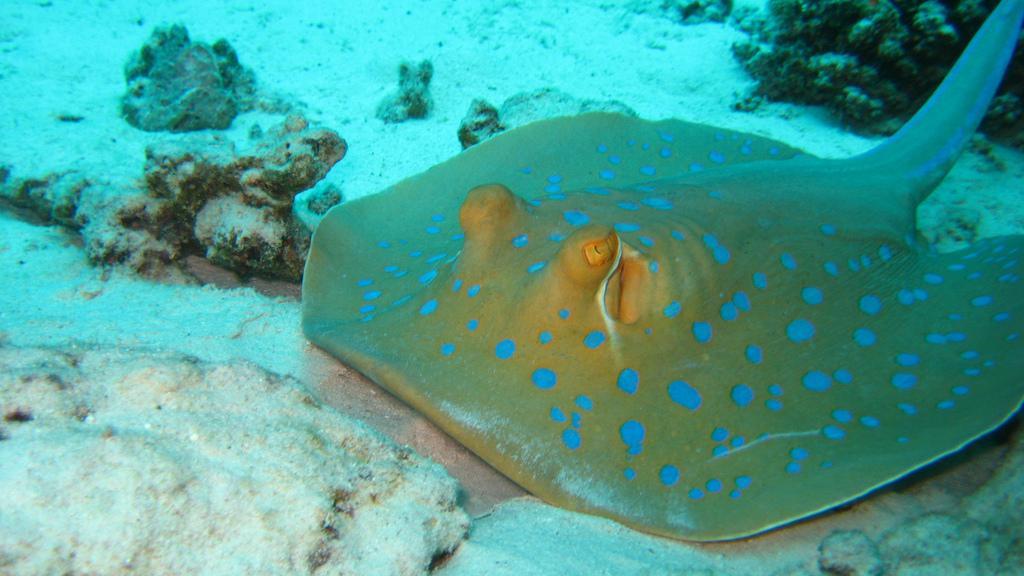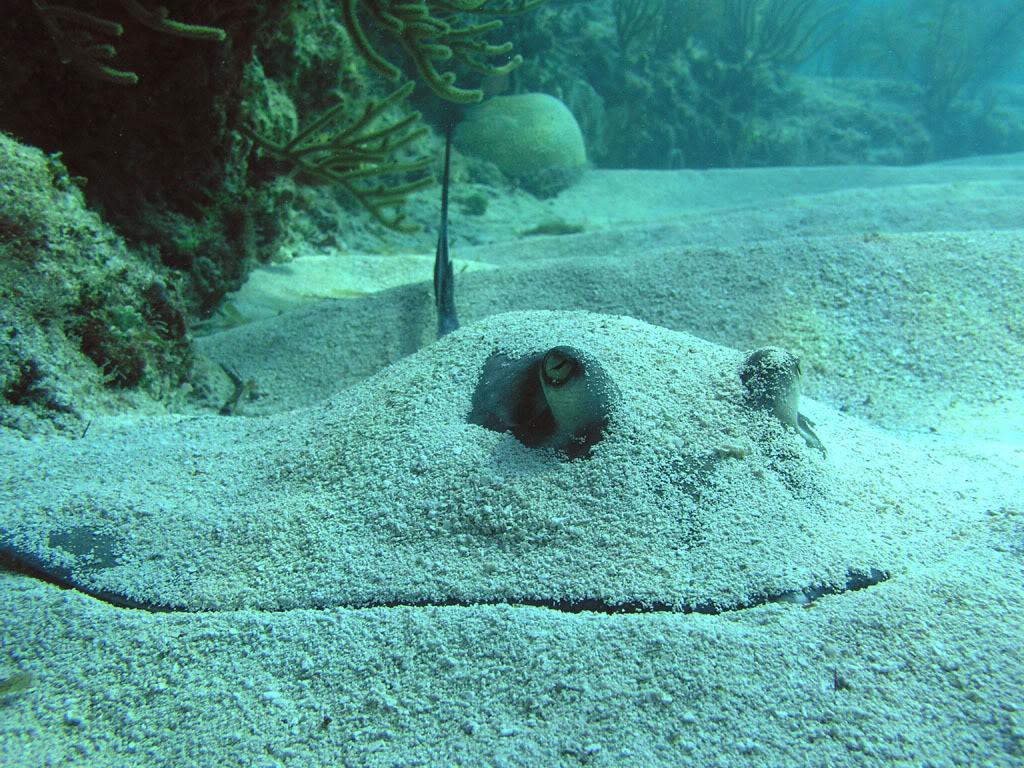The first image is the image on the left, the second image is the image on the right. Evaluate the accuracy of this statement regarding the images: "there are two stingrays per image pair". Is it true? Answer yes or no. Yes. 